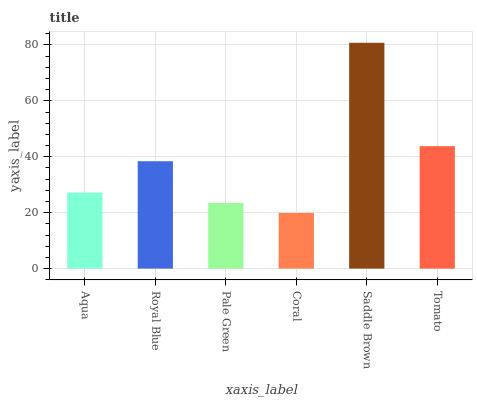Is Coral the minimum?
Answer yes or no. Yes. Is Saddle Brown the maximum?
Answer yes or no. Yes. Is Royal Blue the minimum?
Answer yes or no. No. Is Royal Blue the maximum?
Answer yes or no. No. Is Royal Blue greater than Aqua?
Answer yes or no. Yes. Is Aqua less than Royal Blue?
Answer yes or no. Yes. Is Aqua greater than Royal Blue?
Answer yes or no. No. Is Royal Blue less than Aqua?
Answer yes or no. No. Is Royal Blue the high median?
Answer yes or no. Yes. Is Aqua the low median?
Answer yes or no. Yes. Is Saddle Brown the high median?
Answer yes or no. No. Is Pale Green the low median?
Answer yes or no. No. 